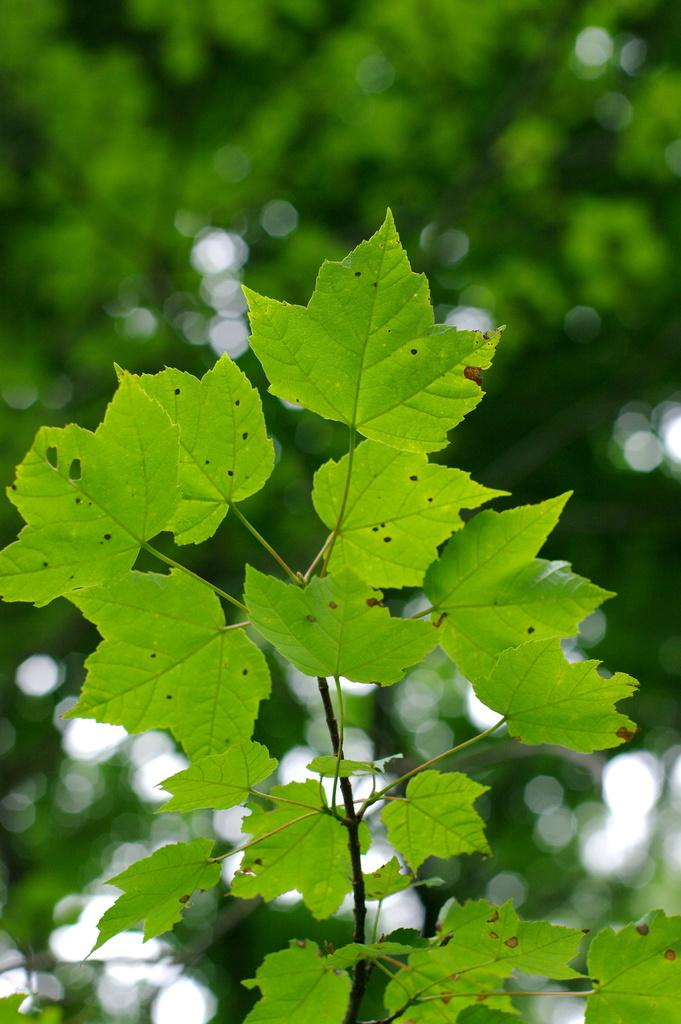What type of living organisms can be seen in the image? Plants and trees are visible in the image. What color are the plants and trees in the image? The plants and trees are green in color. Can you tell me how many dogs are present in the image? There are no dogs present in the image; it features plants and trees. What type of exchange is taking place between the plants and trees in the image? There is no exchange taking place between the plants and trees in the image; they are simply depicted as green living organisms. 